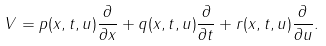Convert formula to latex. <formula><loc_0><loc_0><loc_500><loc_500>V = p ( x , t , u ) \frac { \partial } { \partial x } + q ( x , t , u ) \frac { \partial } { \partial t } + r ( x , t , u ) \frac { \partial } { \partial u } .</formula> 